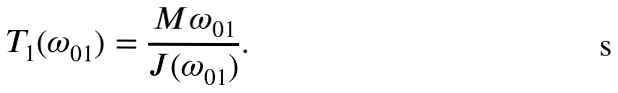<formula> <loc_0><loc_0><loc_500><loc_500>T _ { 1 } ( \omega _ { 0 1 } ) = \frac { M \omega _ { 0 1 } } { J ( \omega _ { 0 1 } ) } .</formula> 